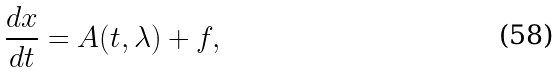Convert formula to latex. <formula><loc_0><loc_0><loc_500><loc_500>\frac { d x } { d t } = A ( t , \lambda ) + f ,</formula> 